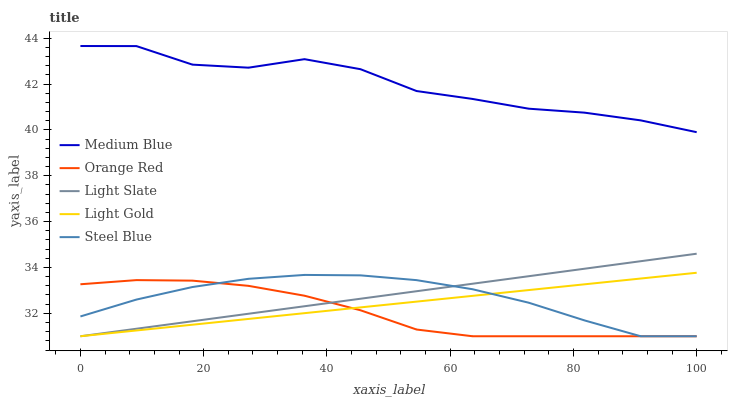Does Orange Red have the minimum area under the curve?
Answer yes or no. Yes. Does Medium Blue have the maximum area under the curve?
Answer yes or no. Yes. Does Light Gold have the minimum area under the curve?
Answer yes or no. No. Does Light Gold have the maximum area under the curve?
Answer yes or no. No. Is Light Gold the smoothest?
Answer yes or no. Yes. Is Medium Blue the roughest?
Answer yes or no. Yes. Is Medium Blue the smoothest?
Answer yes or no. No. Is Light Gold the roughest?
Answer yes or no. No. Does Light Slate have the lowest value?
Answer yes or no. Yes. Does Medium Blue have the lowest value?
Answer yes or no. No. Does Medium Blue have the highest value?
Answer yes or no. Yes. Does Light Gold have the highest value?
Answer yes or no. No. Is Light Gold less than Medium Blue?
Answer yes or no. Yes. Is Medium Blue greater than Light Gold?
Answer yes or no. Yes. Does Light Gold intersect Steel Blue?
Answer yes or no. Yes. Is Light Gold less than Steel Blue?
Answer yes or no. No. Is Light Gold greater than Steel Blue?
Answer yes or no. No. Does Light Gold intersect Medium Blue?
Answer yes or no. No. 